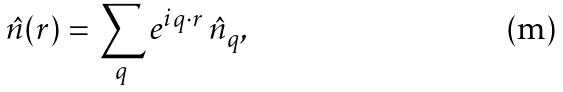Convert formula to latex. <formula><loc_0><loc_0><loc_500><loc_500>\hat { n } ( { r } ) = \sum _ { q } e ^ { i { q \cdot r } } \, \hat { n } _ { q } ,</formula> 